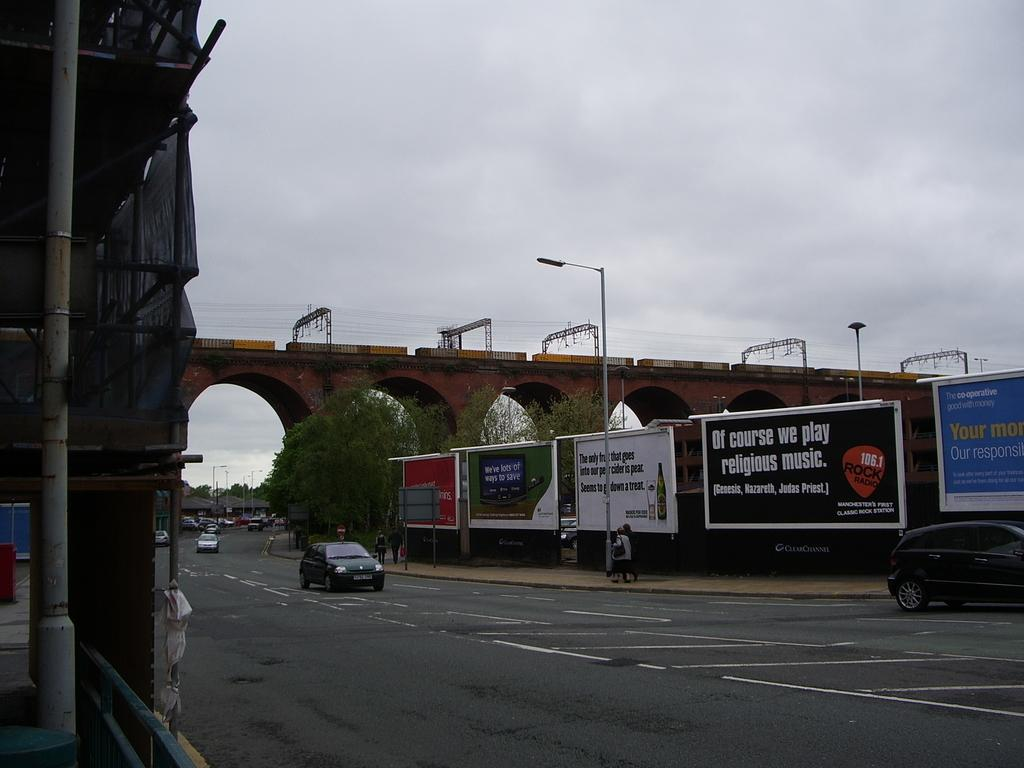What can be seen on the road in the image? There are vehicles on the road in the image. What structure is visible in the background? There is a bridge in the background of the image. How would you describe the sky in the image? The sky is cloudy in the image. Can you see any squirrels climbing the bridge in the image? There are no squirrels visible in the image, and they are not interacting with the bridge. What type of fruit is growing on the vehicles in the image? There are no fruits growing on the vehicles in the image; the image only shows vehicles on the road and a bridge in the background. 